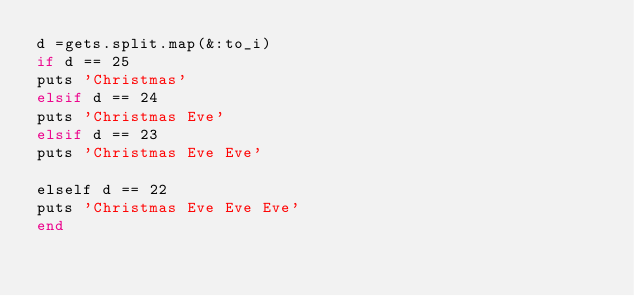<code> <loc_0><loc_0><loc_500><loc_500><_Ruby_>d =gets.split.map(&:to_i)
if d == 25 
puts 'Christmas' 
elsif d == 24 
puts 'Christmas Eve'
elsif d == 23 
puts 'Christmas Eve Eve'
    
elself d == 22 
puts 'Christmas Eve Eve Eve'
end</code> 